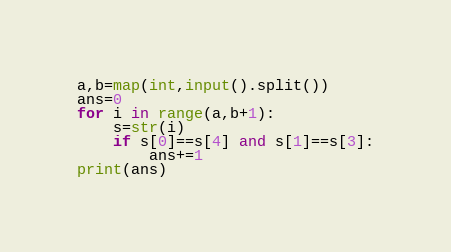<code> <loc_0><loc_0><loc_500><loc_500><_Python_>a,b=map(int,input().split())
ans=0
for i in range(a,b+1):
    s=str(i)
    if s[0]==s[4] and s[1]==s[3]:
        ans+=1
print(ans)</code> 